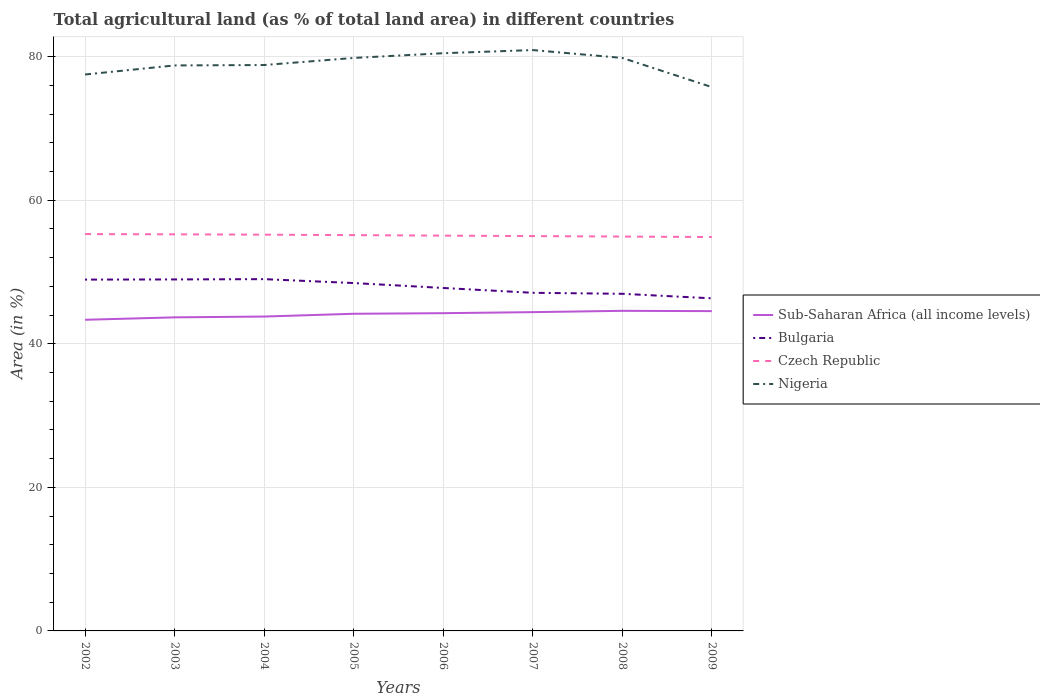How many different coloured lines are there?
Keep it short and to the point. 4. Does the line corresponding to Nigeria intersect with the line corresponding to Bulgaria?
Make the answer very short. No. Is the number of lines equal to the number of legend labels?
Your answer should be compact. Yes. Across all years, what is the maximum percentage of agricultural land in Nigeria?
Provide a succinct answer. 75.76. In which year was the percentage of agricultural land in Bulgaria maximum?
Your answer should be compact. 2009. What is the total percentage of agricultural land in Nigeria in the graph?
Offer a very short reply. -0.66. What is the difference between the highest and the second highest percentage of agricultural land in Sub-Saharan Africa (all income levels)?
Your response must be concise. 1.25. How many years are there in the graph?
Your response must be concise. 8. Where does the legend appear in the graph?
Keep it short and to the point. Center right. How are the legend labels stacked?
Your response must be concise. Vertical. What is the title of the graph?
Offer a very short reply. Total agricultural land (as % of total land area) in different countries. Does "San Marino" appear as one of the legend labels in the graph?
Your answer should be compact. No. What is the label or title of the X-axis?
Your response must be concise. Years. What is the label or title of the Y-axis?
Offer a very short reply. Area (in %). What is the Area (in %) in Sub-Saharan Africa (all income levels) in 2002?
Offer a terse response. 43.34. What is the Area (in %) in Bulgaria in 2002?
Provide a short and direct response. 48.94. What is the Area (in %) in Czech Republic in 2002?
Offer a very short reply. 55.29. What is the Area (in %) in Nigeria in 2002?
Make the answer very short. 77.52. What is the Area (in %) in Sub-Saharan Africa (all income levels) in 2003?
Your response must be concise. 43.68. What is the Area (in %) in Bulgaria in 2003?
Offer a terse response. 48.97. What is the Area (in %) of Czech Republic in 2003?
Provide a succinct answer. 55.25. What is the Area (in %) in Nigeria in 2003?
Keep it short and to the point. 78.78. What is the Area (in %) in Sub-Saharan Africa (all income levels) in 2004?
Your answer should be very brief. 43.8. What is the Area (in %) in Bulgaria in 2004?
Give a very brief answer. 49.01. What is the Area (in %) in Czech Republic in 2004?
Ensure brevity in your answer.  55.2. What is the Area (in %) in Nigeria in 2004?
Make the answer very short. 78.83. What is the Area (in %) in Sub-Saharan Africa (all income levels) in 2005?
Ensure brevity in your answer.  44.18. What is the Area (in %) in Bulgaria in 2005?
Your answer should be compact. 48.46. What is the Area (in %) of Czech Republic in 2005?
Offer a terse response. 55.14. What is the Area (in %) in Nigeria in 2005?
Make the answer very short. 79.82. What is the Area (in %) in Sub-Saharan Africa (all income levels) in 2006?
Your answer should be compact. 44.26. What is the Area (in %) in Bulgaria in 2006?
Your answer should be very brief. 47.78. What is the Area (in %) in Czech Republic in 2006?
Keep it short and to the point. 55.07. What is the Area (in %) of Nigeria in 2006?
Offer a terse response. 80.48. What is the Area (in %) in Sub-Saharan Africa (all income levels) in 2007?
Offer a terse response. 44.41. What is the Area (in %) in Bulgaria in 2007?
Keep it short and to the point. 47.1. What is the Area (in %) in Czech Republic in 2007?
Offer a terse response. 55. What is the Area (in %) of Nigeria in 2007?
Provide a succinct answer. 80.92. What is the Area (in %) of Sub-Saharan Africa (all income levels) in 2008?
Offer a terse response. 44.59. What is the Area (in %) of Bulgaria in 2008?
Offer a very short reply. 46.97. What is the Area (in %) of Czech Republic in 2008?
Keep it short and to the point. 54.94. What is the Area (in %) of Nigeria in 2008?
Ensure brevity in your answer.  79.82. What is the Area (in %) in Sub-Saharan Africa (all income levels) in 2009?
Offer a terse response. 44.55. What is the Area (in %) in Bulgaria in 2009?
Make the answer very short. 46.33. What is the Area (in %) in Czech Republic in 2009?
Provide a succinct answer. 54.87. What is the Area (in %) of Nigeria in 2009?
Provide a short and direct response. 75.76. Across all years, what is the maximum Area (in %) of Sub-Saharan Africa (all income levels)?
Give a very brief answer. 44.59. Across all years, what is the maximum Area (in %) in Bulgaria?
Give a very brief answer. 49.01. Across all years, what is the maximum Area (in %) of Czech Republic?
Ensure brevity in your answer.  55.29. Across all years, what is the maximum Area (in %) in Nigeria?
Your answer should be compact. 80.92. Across all years, what is the minimum Area (in %) in Sub-Saharan Africa (all income levels)?
Your answer should be compact. 43.34. Across all years, what is the minimum Area (in %) of Bulgaria?
Provide a short and direct response. 46.33. Across all years, what is the minimum Area (in %) of Czech Republic?
Provide a short and direct response. 54.87. Across all years, what is the minimum Area (in %) in Nigeria?
Keep it short and to the point. 75.76. What is the total Area (in %) of Sub-Saharan Africa (all income levels) in the graph?
Ensure brevity in your answer.  352.83. What is the total Area (in %) in Bulgaria in the graph?
Your response must be concise. 383.56. What is the total Area (in %) of Czech Republic in the graph?
Ensure brevity in your answer.  440.76. What is the total Area (in %) of Nigeria in the graph?
Make the answer very short. 631.94. What is the difference between the Area (in %) of Sub-Saharan Africa (all income levels) in 2002 and that in 2003?
Give a very brief answer. -0.34. What is the difference between the Area (in %) of Bulgaria in 2002 and that in 2003?
Offer a very short reply. -0.02. What is the difference between the Area (in %) of Czech Republic in 2002 and that in 2003?
Provide a succinct answer. 0.04. What is the difference between the Area (in %) of Nigeria in 2002 and that in 2003?
Your answer should be compact. -1.26. What is the difference between the Area (in %) in Sub-Saharan Africa (all income levels) in 2002 and that in 2004?
Ensure brevity in your answer.  -0.45. What is the difference between the Area (in %) of Bulgaria in 2002 and that in 2004?
Your answer should be very brief. -0.06. What is the difference between the Area (in %) of Czech Republic in 2002 and that in 2004?
Keep it short and to the point. 0.08. What is the difference between the Area (in %) in Nigeria in 2002 and that in 2004?
Give a very brief answer. -1.32. What is the difference between the Area (in %) of Sub-Saharan Africa (all income levels) in 2002 and that in 2005?
Offer a very short reply. -0.84. What is the difference between the Area (in %) of Bulgaria in 2002 and that in 2005?
Provide a succinct answer. 0.48. What is the difference between the Area (in %) of Czech Republic in 2002 and that in 2005?
Provide a succinct answer. 0.15. What is the difference between the Area (in %) of Nigeria in 2002 and that in 2005?
Provide a succinct answer. -2.31. What is the difference between the Area (in %) of Sub-Saharan Africa (all income levels) in 2002 and that in 2006?
Offer a terse response. -0.92. What is the difference between the Area (in %) in Bulgaria in 2002 and that in 2006?
Give a very brief answer. 1.17. What is the difference between the Area (in %) in Czech Republic in 2002 and that in 2006?
Your answer should be compact. 0.22. What is the difference between the Area (in %) in Nigeria in 2002 and that in 2006?
Provide a succinct answer. -2.96. What is the difference between the Area (in %) in Sub-Saharan Africa (all income levels) in 2002 and that in 2007?
Make the answer very short. -1.07. What is the difference between the Area (in %) of Bulgaria in 2002 and that in 2007?
Ensure brevity in your answer.  1.84. What is the difference between the Area (in %) of Czech Republic in 2002 and that in 2007?
Make the answer very short. 0.28. What is the difference between the Area (in %) in Nigeria in 2002 and that in 2007?
Offer a very short reply. -3.4. What is the difference between the Area (in %) in Sub-Saharan Africa (all income levels) in 2002 and that in 2008?
Offer a terse response. -1.25. What is the difference between the Area (in %) of Bulgaria in 2002 and that in 2008?
Your response must be concise. 1.98. What is the difference between the Area (in %) in Czech Republic in 2002 and that in 2008?
Your response must be concise. 0.35. What is the difference between the Area (in %) of Nigeria in 2002 and that in 2008?
Your response must be concise. -2.31. What is the difference between the Area (in %) in Sub-Saharan Africa (all income levels) in 2002 and that in 2009?
Offer a terse response. -1.21. What is the difference between the Area (in %) of Bulgaria in 2002 and that in 2009?
Offer a very short reply. 2.61. What is the difference between the Area (in %) in Czech Republic in 2002 and that in 2009?
Offer a terse response. 0.41. What is the difference between the Area (in %) in Nigeria in 2002 and that in 2009?
Offer a very short reply. 1.76. What is the difference between the Area (in %) in Sub-Saharan Africa (all income levels) in 2003 and that in 2004?
Ensure brevity in your answer.  -0.11. What is the difference between the Area (in %) in Bulgaria in 2003 and that in 2004?
Ensure brevity in your answer.  -0.04. What is the difference between the Area (in %) in Czech Republic in 2003 and that in 2004?
Keep it short and to the point. 0.04. What is the difference between the Area (in %) of Nigeria in 2003 and that in 2004?
Ensure brevity in your answer.  -0.05. What is the difference between the Area (in %) in Sub-Saharan Africa (all income levels) in 2003 and that in 2005?
Offer a very short reply. -0.5. What is the difference between the Area (in %) of Bulgaria in 2003 and that in 2005?
Provide a short and direct response. 0.5. What is the difference between the Area (in %) in Czech Republic in 2003 and that in 2005?
Provide a short and direct response. 0.11. What is the difference between the Area (in %) of Nigeria in 2003 and that in 2005?
Give a very brief answer. -1.04. What is the difference between the Area (in %) in Sub-Saharan Africa (all income levels) in 2003 and that in 2006?
Keep it short and to the point. -0.58. What is the difference between the Area (in %) of Bulgaria in 2003 and that in 2006?
Ensure brevity in your answer.  1.19. What is the difference between the Area (in %) in Czech Republic in 2003 and that in 2006?
Keep it short and to the point. 0.18. What is the difference between the Area (in %) in Nigeria in 2003 and that in 2006?
Provide a succinct answer. -1.7. What is the difference between the Area (in %) of Sub-Saharan Africa (all income levels) in 2003 and that in 2007?
Give a very brief answer. -0.73. What is the difference between the Area (in %) of Bulgaria in 2003 and that in 2007?
Provide a succinct answer. 1.86. What is the difference between the Area (in %) in Czech Republic in 2003 and that in 2007?
Provide a short and direct response. 0.24. What is the difference between the Area (in %) in Nigeria in 2003 and that in 2007?
Offer a terse response. -2.14. What is the difference between the Area (in %) of Sub-Saharan Africa (all income levels) in 2003 and that in 2008?
Keep it short and to the point. -0.91. What is the difference between the Area (in %) in Bulgaria in 2003 and that in 2008?
Keep it short and to the point. 2. What is the difference between the Area (in %) of Czech Republic in 2003 and that in 2008?
Provide a succinct answer. 0.31. What is the difference between the Area (in %) in Nigeria in 2003 and that in 2008?
Offer a very short reply. -1.04. What is the difference between the Area (in %) of Sub-Saharan Africa (all income levels) in 2003 and that in 2009?
Your answer should be very brief. -0.87. What is the difference between the Area (in %) of Bulgaria in 2003 and that in 2009?
Your answer should be compact. 2.63. What is the difference between the Area (in %) in Czech Republic in 2003 and that in 2009?
Ensure brevity in your answer.  0.37. What is the difference between the Area (in %) of Nigeria in 2003 and that in 2009?
Provide a short and direct response. 3.02. What is the difference between the Area (in %) of Sub-Saharan Africa (all income levels) in 2004 and that in 2005?
Your response must be concise. -0.39. What is the difference between the Area (in %) in Bulgaria in 2004 and that in 2005?
Provide a succinct answer. 0.54. What is the difference between the Area (in %) of Czech Republic in 2004 and that in 2005?
Your answer should be compact. 0.06. What is the difference between the Area (in %) of Nigeria in 2004 and that in 2005?
Make the answer very short. -0.99. What is the difference between the Area (in %) of Sub-Saharan Africa (all income levels) in 2004 and that in 2006?
Offer a very short reply. -0.47. What is the difference between the Area (in %) of Bulgaria in 2004 and that in 2006?
Your response must be concise. 1.23. What is the difference between the Area (in %) of Czech Republic in 2004 and that in 2006?
Your answer should be very brief. 0.14. What is the difference between the Area (in %) in Nigeria in 2004 and that in 2006?
Your answer should be compact. -1.65. What is the difference between the Area (in %) in Sub-Saharan Africa (all income levels) in 2004 and that in 2007?
Offer a terse response. -0.61. What is the difference between the Area (in %) of Bulgaria in 2004 and that in 2007?
Offer a very short reply. 1.9. What is the difference between the Area (in %) of Nigeria in 2004 and that in 2007?
Ensure brevity in your answer.  -2.09. What is the difference between the Area (in %) in Sub-Saharan Africa (all income levels) in 2004 and that in 2008?
Ensure brevity in your answer.  -0.8. What is the difference between the Area (in %) of Bulgaria in 2004 and that in 2008?
Provide a succinct answer. 2.04. What is the difference between the Area (in %) of Czech Republic in 2004 and that in 2008?
Offer a very short reply. 0.26. What is the difference between the Area (in %) of Nigeria in 2004 and that in 2008?
Keep it short and to the point. -0.99. What is the difference between the Area (in %) in Sub-Saharan Africa (all income levels) in 2004 and that in 2009?
Offer a terse response. -0.75. What is the difference between the Area (in %) in Bulgaria in 2004 and that in 2009?
Make the answer very short. 2.67. What is the difference between the Area (in %) of Czech Republic in 2004 and that in 2009?
Provide a short and direct response. 0.33. What is the difference between the Area (in %) of Nigeria in 2004 and that in 2009?
Keep it short and to the point. 3.07. What is the difference between the Area (in %) of Sub-Saharan Africa (all income levels) in 2005 and that in 2006?
Provide a short and direct response. -0.08. What is the difference between the Area (in %) of Bulgaria in 2005 and that in 2006?
Ensure brevity in your answer.  0.69. What is the difference between the Area (in %) of Czech Republic in 2005 and that in 2006?
Make the answer very short. 0.07. What is the difference between the Area (in %) in Nigeria in 2005 and that in 2006?
Your answer should be compact. -0.66. What is the difference between the Area (in %) in Sub-Saharan Africa (all income levels) in 2005 and that in 2007?
Your answer should be compact. -0.23. What is the difference between the Area (in %) in Bulgaria in 2005 and that in 2007?
Ensure brevity in your answer.  1.36. What is the difference between the Area (in %) of Czech Republic in 2005 and that in 2007?
Your answer should be compact. 0.14. What is the difference between the Area (in %) of Nigeria in 2005 and that in 2007?
Your response must be concise. -1.1. What is the difference between the Area (in %) of Sub-Saharan Africa (all income levels) in 2005 and that in 2008?
Keep it short and to the point. -0.41. What is the difference between the Area (in %) in Bulgaria in 2005 and that in 2008?
Offer a terse response. 1.5. What is the difference between the Area (in %) of Czech Republic in 2005 and that in 2008?
Offer a very short reply. 0.2. What is the difference between the Area (in %) in Sub-Saharan Africa (all income levels) in 2005 and that in 2009?
Provide a succinct answer. -0.37. What is the difference between the Area (in %) in Bulgaria in 2005 and that in 2009?
Provide a succinct answer. 2.13. What is the difference between the Area (in %) of Czech Republic in 2005 and that in 2009?
Keep it short and to the point. 0.26. What is the difference between the Area (in %) in Nigeria in 2005 and that in 2009?
Offer a terse response. 4.06. What is the difference between the Area (in %) of Sub-Saharan Africa (all income levels) in 2006 and that in 2007?
Your response must be concise. -0.15. What is the difference between the Area (in %) in Bulgaria in 2006 and that in 2007?
Keep it short and to the point. 0.67. What is the difference between the Area (in %) in Czech Republic in 2006 and that in 2007?
Offer a very short reply. 0.06. What is the difference between the Area (in %) of Nigeria in 2006 and that in 2007?
Offer a very short reply. -0.44. What is the difference between the Area (in %) in Sub-Saharan Africa (all income levels) in 2006 and that in 2008?
Provide a short and direct response. -0.33. What is the difference between the Area (in %) in Bulgaria in 2006 and that in 2008?
Offer a very short reply. 0.81. What is the difference between the Area (in %) of Czech Republic in 2006 and that in 2008?
Provide a succinct answer. 0.13. What is the difference between the Area (in %) of Nigeria in 2006 and that in 2008?
Keep it short and to the point. 0.66. What is the difference between the Area (in %) of Sub-Saharan Africa (all income levels) in 2006 and that in 2009?
Give a very brief answer. -0.29. What is the difference between the Area (in %) in Bulgaria in 2006 and that in 2009?
Your answer should be compact. 1.44. What is the difference between the Area (in %) in Czech Republic in 2006 and that in 2009?
Your answer should be compact. 0.19. What is the difference between the Area (in %) of Nigeria in 2006 and that in 2009?
Give a very brief answer. 4.72. What is the difference between the Area (in %) of Sub-Saharan Africa (all income levels) in 2007 and that in 2008?
Provide a succinct answer. -0.18. What is the difference between the Area (in %) in Bulgaria in 2007 and that in 2008?
Offer a very short reply. 0.14. What is the difference between the Area (in %) of Czech Republic in 2007 and that in 2008?
Ensure brevity in your answer.  0.06. What is the difference between the Area (in %) of Nigeria in 2007 and that in 2008?
Offer a very short reply. 1.1. What is the difference between the Area (in %) of Sub-Saharan Africa (all income levels) in 2007 and that in 2009?
Your answer should be very brief. -0.14. What is the difference between the Area (in %) in Bulgaria in 2007 and that in 2009?
Provide a succinct answer. 0.77. What is the difference between the Area (in %) of Czech Republic in 2007 and that in 2009?
Offer a very short reply. 0.13. What is the difference between the Area (in %) in Nigeria in 2007 and that in 2009?
Your response must be concise. 5.16. What is the difference between the Area (in %) in Sub-Saharan Africa (all income levels) in 2008 and that in 2009?
Offer a very short reply. 0.04. What is the difference between the Area (in %) of Bulgaria in 2008 and that in 2009?
Your response must be concise. 0.63. What is the difference between the Area (in %) of Czech Republic in 2008 and that in 2009?
Provide a succinct answer. 0.06. What is the difference between the Area (in %) in Nigeria in 2008 and that in 2009?
Provide a succinct answer. 4.06. What is the difference between the Area (in %) in Sub-Saharan Africa (all income levels) in 2002 and the Area (in %) in Bulgaria in 2003?
Keep it short and to the point. -5.62. What is the difference between the Area (in %) in Sub-Saharan Africa (all income levels) in 2002 and the Area (in %) in Czech Republic in 2003?
Your response must be concise. -11.9. What is the difference between the Area (in %) of Sub-Saharan Africa (all income levels) in 2002 and the Area (in %) of Nigeria in 2003?
Offer a terse response. -35.43. What is the difference between the Area (in %) of Bulgaria in 2002 and the Area (in %) of Czech Republic in 2003?
Give a very brief answer. -6.3. What is the difference between the Area (in %) in Bulgaria in 2002 and the Area (in %) in Nigeria in 2003?
Make the answer very short. -29.84. What is the difference between the Area (in %) of Czech Republic in 2002 and the Area (in %) of Nigeria in 2003?
Offer a very short reply. -23.49. What is the difference between the Area (in %) in Sub-Saharan Africa (all income levels) in 2002 and the Area (in %) in Bulgaria in 2004?
Provide a short and direct response. -5.66. What is the difference between the Area (in %) in Sub-Saharan Africa (all income levels) in 2002 and the Area (in %) in Czech Republic in 2004?
Provide a succinct answer. -11.86. What is the difference between the Area (in %) of Sub-Saharan Africa (all income levels) in 2002 and the Area (in %) of Nigeria in 2004?
Offer a terse response. -35.49. What is the difference between the Area (in %) of Bulgaria in 2002 and the Area (in %) of Czech Republic in 2004?
Ensure brevity in your answer.  -6.26. What is the difference between the Area (in %) in Bulgaria in 2002 and the Area (in %) in Nigeria in 2004?
Give a very brief answer. -29.89. What is the difference between the Area (in %) of Czech Republic in 2002 and the Area (in %) of Nigeria in 2004?
Offer a terse response. -23.55. What is the difference between the Area (in %) of Sub-Saharan Africa (all income levels) in 2002 and the Area (in %) of Bulgaria in 2005?
Offer a very short reply. -5.12. What is the difference between the Area (in %) in Sub-Saharan Africa (all income levels) in 2002 and the Area (in %) in Czech Republic in 2005?
Make the answer very short. -11.79. What is the difference between the Area (in %) of Sub-Saharan Africa (all income levels) in 2002 and the Area (in %) of Nigeria in 2005?
Give a very brief answer. -36.48. What is the difference between the Area (in %) of Bulgaria in 2002 and the Area (in %) of Czech Republic in 2005?
Give a very brief answer. -6.2. What is the difference between the Area (in %) of Bulgaria in 2002 and the Area (in %) of Nigeria in 2005?
Your answer should be very brief. -30.88. What is the difference between the Area (in %) in Czech Republic in 2002 and the Area (in %) in Nigeria in 2005?
Keep it short and to the point. -24.54. What is the difference between the Area (in %) in Sub-Saharan Africa (all income levels) in 2002 and the Area (in %) in Bulgaria in 2006?
Keep it short and to the point. -4.43. What is the difference between the Area (in %) of Sub-Saharan Africa (all income levels) in 2002 and the Area (in %) of Czech Republic in 2006?
Offer a terse response. -11.72. What is the difference between the Area (in %) of Sub-Saharan Africa (all income levels) in 2002 and the Area (in %) of Nigeria in 2006?
Ensure brevity in your answer.  -37.14. What is the difference between the Area (in %) of Bulgaria in 2002 and the Area (in %) of Czech Republic in 2006?
Your response must be concise. -6.12. What is the difference between the Area (in %) in Bulgaria in 2002 and the Area (in %) in Nigeria in 2006?
Provide a short and direct response. -31.54. What is the difference between the Area (in %) of Czech Republic in 2002 and the Area (in %) of Nigeria in 2006?
Your response must be concise. -25.19. What is the difference between the Area (in %) of Sub-Saharan Africa (all income levels) in 2002 and the Area (in %) of Bulgaria in 2007?
Your response must be concise. -3.76. What is the difference between the Area (in %) in Sub-Saharan Africa (all income levels) in 2002 and the Area (in %) in Czech Republic in 2007?
Give a very brief answer. -11.66. What is the difference between the Area (in %) of Sub-Saharan Africa (all income levels) in 2002 and the Area (in %) of Nigeria in 2007?
Provide a short and direct response. -37.58. What is the difference between the Area (in %) of Bulgaria in 2002 and the Area (in %) of Czech Republic in 2007?
Your response must be concise. -6.06. What is the difference between the Area (in %) of Bulgaria in 2002 and the Area (in %) of Nigeria in 2007?
Make the answer very short. -31.98. What is the difference between the Area (in %) of Czech Republic in 2002 and the Area (in %) of Nigeria in 2007?
Offer a very short reply. -25.63. What is the difference between the Area (in %) in Sub-Saharan Africa (all income levels) in 2002 and the Area (in %) in Bulgaria in 2008?
Offer a very short reply. -3.62. What is the difference between the Area (in %) in Sub-Saharan Africa (all income levels) in 2002 and the Area (in %) in Czech Republic in 2008?
Make the answer very short. -11.59. What is the difference between the Area (in %) in Sub-Saharan Africa (all income levels) in 2002 and the Area (in %) in Nigeria in 2008?
Give a very brief answer. -36.48. What is the difference between the Area (in %) in Bulgaria in 2002 and the Area (in %) in Czech Republic in 2008?
Provide a succinct answer. -6. What is the difference between the Area (in %) in Bulgaria in 2002 and the Area (in %) in Nigeria in 2008?
Ensure brevity in your answer.  -30.88. What is the difference between the Area (in %) in Czech Republic in 2002 and the Area (in %) in Nigeria in 2008?
Provide a short and direct response. -24.54. What is the difference between the Area (in %) of Sub-Saharan Africa (all income levels) in 2002 and the Area (in %) of Bulgaria in 2009?
Offer a terse response. -2.99. What is the difference between the Area (in %) of Sub-Saharan Africa (all income levels) in 2002 and the Area (in %) of Czech Republic in 2009?
Provide a succinct answer. -11.53. What is the difference between the Area (in %) in Sub-Saharan Africa (all income levels) in 2002 and the Area (in %) in Nigeria in 2009?
Keep it short and to the point. -32.42. What is the difference between the Area (in %) in Bulgaria in 2002 and the Area (in %) in Czech Republic in 2009?
Offer a terse response. -5.93. What is the difference between the Area (in %) in Bulgaria in 2002 and the Area (in %) in Nigeria in 2009?
Make the answer very short. -26.82. What is the difference between the Area (in %) of Czech Republic in 2002 and the Area (in %) of Nigeria in 2009?
Give a very brief answer. -20.47. What is the difference between the Area (in %) of Sub-Saharan Africa (all income levels) in 2003 and the Area (in %) of Bulgaria in 2004?
Offer a terse response. -5.33. What is the difference between the Area (in %) in Sub-Saharan Africa (all income levels) in 2003 and the Area (in %) in Czech Republic in 2004?
Make the answer very short. -11.52. What is the difference between the Area (in %) of Sub-Saharan Africa (all income levels) in 2003 and the Area (in %) of Nigeria in 2004?
Give a very brief answer. -35.15. What is the difference between the Area (in %) in Bulgaria in 2003 and the Area (in %) in Czech Republic in 2004?
Provide a short and direct response. -6.24. What is the difference between the Area (in %) in Bulgaria in 2003 and the Area (in %) in Nigeria in 2004?
Ensure brevity in your answer.  -29.87. What is the difference between the Area (in %) of Czech Republic in 2003 and the Area (in %) of Nigeria in 2004?
Your answer should be very brief. -23.59. What is the difference between the Area (in %) in Sub-Saharan Africa (all income levels) in 2003 and the Area (in %) in Bulgaria in 2005?
Offer a very short reply. -4.78. What is the difference between the Area (in %) in Sub-Saharan Africa (all income levels) in 2003 and the Area (in %) in Czech Republic in 2005?
Your answer should be compact. -11.46. What is the difference between the Area (in %) of Sub-Saharan Africa (all income levels) in 2003 and the Area (in %) of Nigeria in 2005?
Keep it short and to the point. -36.14. What is the difference between the Area (in %) in Bulgaria in 2003 and the Area (in %) in Czech Republic in 2005?
Provide a short and direct response. -6.17. What is the difference between the Area (in %) in Bulgaria in 2003 and the Area (in %) in Nigeria in 2005?
Your answer should be compact. -30.86. What is the difference between the Area (in %) of Czech Republic in 2003 and the Area (in %) of Nigeria in 2005?
Offer a terse response. -24.57. What is the difference between the Area (in %) of Sub-Saharan Africa (all income levels) in 2003 and the Area (in %) of Bulgaria in 2006?
Your answer should be compact. -4.09. What is the difference between the Area (in %) of Sub-Saharan Africa (all income levels) in 2003 and the Area (in %) of Czech Republic in 2006?
Your answer should be compact. -11.39. What is the difference between the Area (in %) in Sub-Saharan Africa (all income levels) in 2003 and the Area (in %) in Nigeria in 2006?
Ensure brevity in your answer.  -36.8. What is the difference between the Area (in %) of Bulgaria in 2003 and the Area (in %) of Czech Republic in 2006?
Provide a succinct answer. -6.1. What is the difference between the Area (in %) of Bulgaria in 2003 and the Area (in %) of Nigeria in 2006?
Provide a succinct answer. -31.52. What is the difference between the Area (in %) in Czech Republic in 2003 and the Area (in %) in Nigeria in 2006?
Make the answer very short. -25.23. What is the difference between the Area (in %) of Sub-Saharan Africa (all income levels) in 2003 and the Area (in %) of Bulgaria in 2007?
Ensure brevity in your answer.  -3.42. What is the difference between the Area (in %) of Sub-Saharan Africa (all income levels) in 2003 and the Area (in %) of Czech Republic in 2007?
Provide a short and direct response. -11.32. What is the difference between the Area (in %) in Sub-Saharan Africa (all income levels) in 2003 and the Area (in %) in Nigeria in 2007?
Offer a terse response. -37.24. What is the difference between the Area (in %) in Bulgaria in 2003 and the Area (in %) in Czech Republic in 2007?
Your response must be concise. -6.04. What is the difference between the Area (in %) of Bulgaria in 2003 and the Area (in %) of Nigeria in 2007?
Make the answer very short. -31.95. What is the difference between the Area (in %) in Czech Republic in 2003 and the Area (in %) in Nigeria in 2007?
Provide a short and direct response. -25.67. What is the difference between the Area (in %) of Sub-Saharan Africa (all income levels) in 2003 and the Area (in %) of Bulgaria in 2008?
Offer a terse response. -3.28. What is the difference between the Area (in %) of Sub-Saharan Africa (all income levels) in 2003 and the Area (in %) of Czech Republic in 2008?
Your answer should be very brief. -11.26. What is the difference between the Area (in %) in Sub-Saharan Africa (all income levels) in 2003 and the Area (in %) in Nigeria in 2008?
Offer a terse response. -36.14. What is the difference between the Area (in %) in Bulgaria in 2003 and the Area (in %) in Czech Republic in 2008?
Keep it short and to the point. -5.97. What is the difference between the Area (in %) in Bulgaria in 2003 and the Area (in %) in Nigeria in 2008?
Keep it short and to the point. -30.86. What is the difference between the Area (in %) of Czech Republic in 2003 and the Area (in %) of Nigeria in 2008?
Provide a short and direct response. -24.57. What is the difference between the Area (in %) of Sub-Saharan Africa (all income levels) in 2003 and the Area (in %) of Bulgaria in 2009?
Keep it short and to the point. -2.65. What is the difference between the Area (in %) of Sub-Saharan Africa (all income levels) in 2003 and the Area (in %) of Czech Republic in 2009?
Make the answer very short. -11.19. What is the difference between the Area (in %) in Sub-Saharan Africa (all income levels) in 2003 and the Area (in %) in Nigeria in 2009?
Keep it short and to the point. -32.08. What is the difference between the Area (in %) of Bulgaria in 2003 and the Area (in %) of Czech Republic in 2009?
Give a very brief answer. -5.91. What is the difference between the Area (in %) of Bulgaria in 2003 and the Area (in %) of Nigeria in 2009?
Offer a very short reply. -26.79. What is the difference between the Area (in %) of Czech Republic in 2003 and the Area (in %) of Nigeria in 2009?
Provide a short and direct response. -20.51. What is the difference between the Area (in %) in Sub-Saharan Africa (all income levels) in 2004 and the Area (in %) in Bulgaria in 2005?
Give a very brief answer. -4.67. What is the difference between the Area (in %) in Sub-Saharan Africa (all income levels) in 2004 and the Area (in %) in Czech Republic in 2005?
Your answer should be very brief. -11.34. What is the difference between the Area (in %) of Sub-Saharan Africa (all income levels) in 2004 and the Area (in %) of Nigeria in 2005?
Your answer should be compact. -36.03. What is the difference between the Area (in %) in Bulgaria in 2004 and the Area (in %) in Czech Republic in 2005?
Keep it short and to the point. -6.13. What is the difference between the Area (in %) of Bulgaria in 2004 and the Area (in %) of Nigeria in 2005?
Offer a very short reply. -30.82. What is the difference between the Area (in %) in Czech Republic in 2004 and the Area (in %) in Nigeria in 2005?
Make the answer very short. -24.62. What is the difference between the Area (in %) in Sub-Saharan Africa (all income levels) in 2004 and the Area (in %) in Bulgaria in 2006?
Offer a very short reply. -3.98. What is the difference between the Area (in %) of Sub-Saharan Africa (all income levels) in 2004 and the Area (in %) of Czech Republic in 2006?
Offer a very short reply. -11.27. What is the difference between the Area (in %) in Sub-Saharan Africa (all income levels) in 2004 and the Area (in %) in Nigeria in 2006?
Keep it short and to the point. -36.69. What is the difference between the Area (in %) in Bulgaria in 2004 and the Area (in %) in Czech Republic in 2006?
Offer a terse response. -6.06. What is the difference between the Area (in %) in Bulgaria in 2004 and the Area (in %) in Nigeria in 2006?
Provide a succinct answer. -31.47. What is the difference between the Area (in %) in Czech Republic in 2004 and the Area (in %) in Nigeria in 2006?
Give a very brief answer. -25.28. What is the difference between the Area (in %) in Sub-Saharan Africa (all income levels) in 2004 and the Area (in %) in Bulgaria in 2007?
Make the answer very short. -3.31. What is the difference between the Area (in %) of Sub-Saharan Africa (all income levels) in 2004 and the Area (in %) of Czech Republic in 2007?
Your answer should be compact. -11.21. What is the difference between the Area (in %) of Sub-Saharan Africa (all income levels) in 2004 and the Area (in %) of Nigeria in 2007?
Your answer should be very brief. -37.12. What is the difference between the Area (in %) of Bulgaria in 2004 and the Area (in %) of Czech Republic in 2007?
Make the answer very short. -6. What is the difference between the Area (in %) in Bulgaria in 2004 and the Area (in %) in Nigeria in 2007?
Give a very brief answer. -31.91. What is the difference between the Area (in %) in Czech Republic in 2004 and the Area (in %) in Nigeria in 2007?
Provide a short and direct response. -25.72. What is the difference between the Area (in %) of Sub-Saharan Africa (all income levels) in 2004 and the Area (in %) of Bulgaria in 2008?
Your answer should be compact. -3.17. What is the difference between the Area (in %) in Sub-Saharan Africa (all income levels) in 2004 and the Area (in %) in Czech Republic in 2008?
Ensure brevity in your answer.  -11.14. What is the difference between the Area (in %) in Sub-Saharan Africa (all income levels) in 2004 and the Area (in %) in Nigeria in 2008?
Keep it short and to the point. -36.03. What is the difference between the Area (in %) in Bulgaria in 2004 and the Area (in %) in Czech Republic in 2008?
Give a very brief answer. -5.93. What is the difference between the Area (in %) of Bulgaria in 2004 and the Area (in %) of Nigeria in 2008?
Make the answer very short. -30.82. What is the difference between the Area (in %) of Czech Republic in 2004 and the Area (in %) of Nigeria in 2008?
Make the answer very short. -24.62. What is the difference between the Area (in %) in Sub-Saharan Africa (all income levels) in 2004 and the Area (in %) in Bulgaria in 2009?
Give a very brief answer. -2.54. What is the difference between the Area (in %) in Sub-Saharan Africa (all income levels) in 2004 and the Area (in %) in Czech Republic in 2009?
Your answer should be very brief. -11.08. What is the difference between the Area (in %) of Sub-Saharan Africa (all income levels) in 2004 and the Area (in %) of Nigeria in 2009?
Offer a terse response. -31.96. What is the difference between the Area (in %) in Bulgaria in 2004 and the Area (in %) in Czech Republic in 2009?
Your answer should be very brief. -5.87. What is the difference between the Area (in %) in Bulgaria in 2004 and the Area (in %) in Nigeria in 2009?
Offer a terse response. -26.75. What is the difference between the Area (in %) in Czech Republic in 2004 and the Area (in %) in Nigeria in 2009?
Give a very brief answer. -20.56. What is the difference between the Area (in %) in Sub-Saharan Africa (all income levels) in 2005 and the Area (in %) in Bulgaria in 2006?
Give a very brief answer. -3.59. What is the difference between the Area (in %) in Sub-Saharan Africa (all income levels) in 2005 and the Area (in %) in Czech Republic in 2006?
Provide a short and direct response. -10.88. What is the difference between the Area (in %) of Sub-Saharan Africa (all income levels) in 2005 and the Area (in %) of Nigeria in 2006?
Provide a succinct answer. -36.3. What is the difference between the Area (in %) in Bulgaria in 2005 and the Area (in %) in Czech Republic in 2006?
Ensure brevity in your answer.  -6.61. What is the difference between the Area (in %) of Bulgaria in 2005 and the Area (in %) of Nigeria in 2006?
Your answer should be compact. -32.02. What is the difference between the Area (in %) in Czech Republic in 2005 and the Area (in %) in Nigeria in 2006?
Your answer should be very brief. -25.34. What is the difference between the Area (in %) in Sub-Saharan Africa (all income levels) in 2005 and the Area (in %) in Bulgaria in 2007?
Your response must be concise. -2.92. What is the difference between the Area (in %) in Sub-Saharan Africa (all income levels) in 2005 and the Area (in %) in Czech Republic in 2007?
Make the answer very short. -10.82. What is the difference between the Area (in %) in Sub-Saharan Africa (all income levels) in 2005 and the Area (in %) in Nigeria in 2007?
Your answer should be very brief. -36.74. What is the difference between the Area (in %) in Bulgaria in 2005 and the Area (in %) in Czech Republic in 2007?
Make the answer very short. -6.54. What is the difference between the Area (in %) in Bulgaria in 2005 and the Area (in %) in Nigeria in 2007?
Offer a terse response. -32.46. What is the difference between the Area (in %) of Czech Republic in 2005 and the Area (in %) of Nigeria in 2007?
Ensure brevity in your answer.  -25.78. What is the difference between the Area (in %) in Sub-Saharan Africa (all income levels) in 2005 and the Area (in %) in Bulgaria in 2008?
Offer a terse response. -2.78. What is the difference between the Area (in %) in Sub-Saharan Africa (all income levels) in 2005 and the Area (in %) in Czech Republic in 2008?
Ensure brevity in your answer.  -10.75. What is the difference between the Area (in %) in Sub-Saharan Africa (all income levels) in 2005 and the Area (in %) in Nigeria in 2008?
Ensure brevity in your answer.  -35.64. What is the difference between the Area (in %) in Bulgaria in 2005 and the Area (in %) in Czech Republic in 2008?
Your answer should be very brief. -6.48. What is the difference between the Area (in %) of Bulgaria in 2005 and the Area (in %) of Nigeria in 2008?
Make the answer very short. -31.36. What is the difference between the Area (in %) in Czech Republic in 2005 and the Area (in %) in Nigeria in 2008?
Offer a very short reply. -24.68. What is the difference between the Area (in %) in Sub-Saharan Africa (all income levels) in 2005 and the Area (in %) in Bulgaria in 2009?
Provide a short and direct response. -2.15. What is the difference between the Area (in %) in Sub-Saharan Africa (all income levels) in 2005 and the Area (in %) in Czech Republic in 2009?
Ensure brevity in your answer.  -10.69. What is the difference between the Area (in %) in Sub-Saharan Africa (all income levels) in 2005 and the Area (in %) in Nigeria in 2009?
Your answer should be compact. -31.58. What is the difference between the Area (in %) of Bulgaria in 2005 and the Area (in %) of Czech Republic in 2009?
Provide a succinct answer. -6.41. What is the difference between the Area (in %) of Bulgaria in 2005 and the Area (in %) of Nigeria in 2009?
Offer a very short reply. -27.3. What is the difference between the Area (in %) of Czech Republic in 2005 and the Area (in %) of Nigeria in 2009?
Your answer should be compact. -20.62. What is the difference between the Area (in %) of Sub-Saharan Africa (all income levels) in 2006 and the Area (in %) of Bulgaria in 2007?
Provide a short and direct response. -2.84. What is the difference between the Area (in %) of Sub-Saharan Africa (all income levels) in 2006 and the Area (in %) of Czech Republic in 2007?
Your answer should be very brief. -10.74. What is the difference between the Area (in %) of Sub-Saharan Africa (all income levels) in 2006 and the Area (in %) of Nigeria in 2007?
Your answer should be very brief. -36.66. What is the difference between the Area (in %) of Bulgaria in 2006 and the Area (in %) of Czech Republic in 2007?
Offer a terse response. -7.23. What is the difference between the Area (in %) of Bulgaria in 2006 and the Area (in %) of Nigeria in 2007?
Your answer should be very brief. -33.14. What is the difference between the Area (in %) in Czech Republic in 2006 and the Area (in %) in Nigeria in 2007?
Your answer should be very brief. -25.85. What is the difference between the Area (in %) in Sub-Saharan Africa (all income levels) in 2006 and the Area (in %) in Bulgaria in 2008?
Your response must be concise. -2.7. What is the difference between the Area (in %) in Sub-Saharan Africa (all income levels) in 2006 and the Area (in %) in Czech Republic in 2008?
Provide a short and direct response. -10.67. What is the difference between the Area (in %) of Sub-Saharan Africa (all income levels) in 2006 and the Area (in %) of Nigeria in 2008?
Make the answer very short. -35.56. What is the difference between the Area (in %) of Bulgaria in 2006 and the Area (in %) of Czech Republic in 2008?
Give a very brief answer. -7.16. What is the difference between the Area (in %) in Bulgaria in 2006 and the Area (in %) in Nigeria in 2008?
Offer a very short reply. -32.05. What is the difference between the Area (in %) in Czech Republic in 2006 and the Area (in %) in Nigeria in 2008?
Offer a terse response. -24.75. What is the difference between the Area (in %) in Sub-Saharan Africa (all income levels) in 2006 and the Area (in %) in Bulgaria in 2009?
Offer a terse response. -2.07. What is the difference between the Area (in %) in Sub-Saharan Africa (all income levels) in 2006 and the Area (in %) in Czech Republic in 2009?
Your answer should be compact. -10.61. What is the difference between the Area (in %) of Sub-Saharan Africa (all income levels) in 2006 and the Area (in %) of Nigeria in 2009?
Your answer should be compact. -31.5. What is the difference between the Area (in %) of Bulgaria in 2006 and the Area (in %) of Czech Republic in 2009?
Provide a short and direct response. -7.1. What is the difference between the Area (in %) in Bulgaria in 2006 and the Area (in %) in Nigeria in 2009?
Your answer should be very brief. -27.98. What is the difference between the Area (in %) of Czech Republic in 2006 and the Area (in %) of Nigeria in 2009?
Provide a succinct answer. -20.69. What is the difference between the Area (in %) in Sub-Saharan Africa (all income levels) in 2007 and the Area (in %) in Bulgaria in 2008?
Make the answer very short. -2.56. What is the difference between the Area (in %) of Sub-Saharan Africa (all income levels) in 2007 and the Area (in %) of Czech Republic in 2008?
Give a very brief answer. -10.53. What is the difference between the Area (in %) in Sub-Saharan Africa (all income levels) in 2007 and the Area (in %) in Nigeria in 2008?
Offer a very short reply. -35.41. What is the difference between the Area (in %) in Bulgaria in 2007 and the Area (in %) in Czech Republic in 2008?
Your answer should be compact. -7.83. What is the difference between the Area (in %) of Bulgaria in 2007 and the Area (in %) of Nigeria in 2008?
Your answer should be compact. -32.72. What is the difference between the Area (in %) in Czech Republic in 2007 and the Area (in %) in Nigeria in 2008?
Provide a succinct answer. -24.82. What is the difference between the Area (in %) of Sub-Saharan Africa (all income levels) in 2007 and the Area (in %) of Bulgaria in 2009?
Offer a very short reply. -1.92. What is the difference between the Area (in %) in Sub-Saharan Africa (all income levels) in 2007 and the Area (in %) in Czech Republic in 2009?
Provide a short and direct response. -10.46. What is the difference between the Area (in %) in Sub-Saharan Africa (all income levels) in 2007 and the Area (in %) in Nigeria in 2009?
Your answer should be very brief. -31.35. What is the difference between the Area (in %) of Bulgaria in 2007 and the Area (in %) of Czech Republic in 2009?
Ensure brevity in your answer.  -7.77. What is the difference between the Area (in %) of Bulgaria in 2007 and the Area (in %) of Nigeria in 2009?
Ensure brevity in your answer.  -28.66. What is the difference between the Area (in %) in Czech Republic in 2007 and the Area (in %) in Nigeria in 2009?
Make the answer very short. -20.76. What is the difference between the Area (in %) of Sub-Saharan Africa (all income levels) in 2008 and the Area (in %) of Bulgaria in 2009?
Ensure brevity in your answer.  -1.74. What is the difference between the Area (in %) of Sub-Saharan Africa (all income levels) in 2008 and the Area (in %) of Czech Republic in 2009?
Ensure brevity in your answer.  -10.28. What is the difference between the Area (in %) in Sub-Saharan Africa (all income levels) in 2008 and the Area (in %) in Nigeria in 2009?
Provide a short and direct response. -31.17. What is the difference between the Area (in %) of Bulgaria in 2008 and the Area (in %) of Czech Republic in 2009?
Keep it short and to the point. -7.91. What is the difference between the Area (in %) in Bulgaria in 2008 and the Area (in %) in Nigeria in 2009?
Your answer should be compact. -28.79. What is the difference between the Area (in %) of Czech Republic in 2008 and the Area (in %) of Nigeria in 2009?
Keep it short and to the point. -20.82. What is the average Area (in %) in Sub-Saharan Africa (all income levels) per year?
Ensure brevity in your answer.  44.1. What is the average Area (in %) in Bulgaria per year?
Provide a short and direct response. 47.95. What is the average Area (in %) of Czech Republic per year?
Your response must be concise. 55.09. What is the average Area (in %) in Nigeria per year?
Your response must be concise. 78.99. In the year 2002, what is the difference between the Area (in %) in Sub-Saharan Africa (all income levels) and Area (in %) in Bulgaria?
Offer a terse response. -5.6. In the year 2002, what is the difference between the Area (in %) in Sub-Saharan Africa (all income levels) and Area (in %) in Czech Republic?
Your response must be concise. -11.94. In the year 2002, what is the difference between the Area (in %) in Sub-Saharan Africa (all income levels) and Area (in %) in Nigeria?
Your answer should be compact. -34.17. In the year 2002, what is the difference between the Area (in %) of Bulgaria and Area (in %) of Czech Republic?
Your answer should be compact. -6.34. In the year 2002, what is the difference between the Area (in %) of Bulgaria and Area (in %) of Nigeria?
Provide a succinct answer. -28.57. In the year 2002, what is the difference between the Area (in %) in Czech Republic and Area (in %) in Nigeria?
Your response must be concise. -22.23. In the year 2003, what is the difference between the Area (in %) of Sub-Saharan Africa (all income levels) and Area (in %) of Bulgaria?
Ensure brevity in your answer.  -5.28. In the year 2003, what is the difference between the Area (in %) in Sub-Saharan Africa (all income levels) and Area (in %) in Czech Republic?
Offer a terse response. -11.57. In the year 2003, what is the difference between the Area (in %) in Sub-Saharan Africa (all income levels) and Area (in %) in Nigeria?
Your answer should be compact. -35.1. In the year 2003, what is the difference between the Area (in %) in Bulgaria and Area (in %) in Czech Republic?
Make the answer very short. -6.28. In the year 2003, what is the difference between the Area (in %) of Bulgaria and Area (in %) of Nigeria?
Keep it short and to the point. -29.81. In the year 2003, what is the difference between the Area (in %) in Czech Republic and Area (in %) in Nigeria?
Your response must be concise. -23.53. In the year 2004, what is the difference between the Area (in %) in Sub-Saharan Africa (all income levels) and Area (in %) in Bulgaria?
Provide a short and direct response. -5.21. In the year 2004, what is the difference between the Area (in %) in Sub-Saharan Africa (all income levels) and Area (in %) in Czech Republic?
Your response must be concise. -11.41. In the year 2004, what is the difference between the Area (in %) in Sub-Saharan Africa (all income levels) and Area (in %) in Nigeria?
Your answer should be compact. -35.04. In the year 2004, what is the difference between the Area (in %) of Bulgaria and Area (in %) of Czech Republic?
Offer a very short reply. -6.2. In the year 2004, what is the difference between the Area (in %) of Bulgaria and Area (in %) of Nigeria?
Provide a succinct answer. -29.83. In the year 2004, what is the difference between the Area (in %) in Czech Republic and Area (in %) in Nigeria?
Keep it short and to the point. -23.63. In the year 2005, what is the difference between the Area (in %) in Sub-Saharan Africa (all income levels) and Area (in %) in Bulgaria?
Your answer should be very brief. -4.28. In the year 2005, what is the difference between the Area (in %) of Sub-Saharan Africa (all income levels) and Area (in %) of Czech Republic?
Your response must be concise. -10.95. In the year 2005, what is the difference between the Area (in %) in Sub-Saharan Africa (all income levels) and Area (in %) in Nigeria?
Your answer should be compact. -35.64. In the year 2005, what is the difference between the Area (in %) in Bulgaria and Area (in %) in Czech Republic?
Provide a succinct answer. -6.68. In the year 2005, what is the difference between the Area (in %) of Bulgaria and Area (in %) of Nigeria?
Provide a short and direct response. -31.36. In the year 2005, what is the difference between the Area (in %) in Czech Republic and Area (in %) in Nigeria?
Your response must be concise. -24.68. In the year 2006, what is the difference between the Area (in %) in Sub-Saharan Africa (all income levels) and Area (in %) in Bulgaria?
Offer a terse response. -3.51. In the year 2006, what is the difference between the Area (in %) in Sub-Saharan Africa (all income levels) and Area (in %) in Czech Republic?
Keep it short and to the point. -10.8. In the year 2006, what is the difference between the Area (in %) of Sub-Saharan Africa (all income levels) and Area (in %) of Nigeria?
Give a very brief answer. -36.22. In the year 2006, what is the difference between the Area (in %) in Bulgaria and Area (in %) in Czech Republic?
Offer a very short reply. -7.29. In the year 2006, what is the difference between the Area (in %) in Bulgaria and Area (in %) in Nigeria?
Ensure brevity in your answer.  -32.7. In the year 2006, what is the difference between the Area (in %) of Czech Republic and Area (in %) of Nigeria?
Make the answer very short. -25.41. In the year 2007, what is the difference between the Area (in %) in Sub-Saharan Africa (all income levels) and Area (in %) in Bulgaria?
Provide a short and direct response. -2.69. In the year 2007, what is the difference between the Area (in %) of Sub-Saharan Africa (all income levels) and Area (in %) of Czech Republic?
Make the answer very short. -10.59. In the year 2007, what is the difference between the Area (in %) of Sub-Saharan Africa (all income levels) and Area (in %) of Nigeria?
Provide a succinct answer. -36.51. In the year 2007, what is the difference between the Area (in %) of Bulgaria and Area (in %) of Czech Republic?
Your answer should be compact. -7.9. In the year 2007, what is the difference between the Area (in %) in Bulgaria and Area (in %) in Nigeria?
Provide a short and direct response. -33.82. In the year 2007, what is the difference between the Area (in %) of Czech Republic and Area (in %) of Nigeria?
Provide a short and direct response. -25.92. In the year 2008, what is the difference between the Area (in %) in Sub-Saharan Africa (all income levels) and Area (in %) in Bulgaria?
Your answer should be compact. -2.37. In the year 2008, what is the difference between the Area (in %) in Sub-Saharan Africa (all income levels) and Area (in %) in Czech Republic?
Offer a terse response. -10.35. In the year 2008, what is the difference between the Area (in %) in Sub-Saharan Africa (all income levels) and Area (in %) in Nigeria?
Your answer should be very brief. -35.23. In the year 2008, what is the difference between the Area (in %) of Bulgaria and Area (in %) of Czech Republic?
Ensure brevity in your answer.  -7.97. In the year 2008, what is the difference between the Area (in %) in Bulgaria and Area (in %) in Nigeria?
Keep it short and to the point. -32.86. In the year 2008, what is the difference between the Area (in %) of Czech Republic and Area (in %) of Nigeria?
Your answer should be very brief. -24.88. In the year 2009, what is the difference between the Area (in %) in Sub-Saharan Africa (all income levels) and Area (in %) in Bulgaria?
Provide a succinct answer. -1.78. In the year 2009, what is the difference between the Area (in %) of Sub-Saharan Africa (all income levels) and Area (in %) of Czech Republic?
Provide a succinct answer. -10.32. In the year 2009, what is the difference between the Area (in %) of Sub-Saharan Africa (all income levels) and Area (in %) of Nigeria?
Provide a succinct answer. -31.21. In the year 2009, what is the difference between the Area (in %) of Bulgaria and Area (in %) of Czech Republic?
Keep it short and to the point. -8.54. In the year 2009, what is the difference between the Area (in %) of Bulgaria and Area (in %) of Nigeria?
Provide a short and direct response. -29.43. In the year 2009, what is the difference between the Area (in %) in Czech Republic and Area (in %) in Nigeria?
Give a very brief answer. -20.89. What is the ratio of the Area (in %) in Sub-Saharan Africa (all income levels) in 2002 to that in 2003?
Your answer should be compact. 0.99. What is the ratio of the Area (in %) in Bulgaria in 2002 to that in 2003?
Your answer should be very brief. 1. What is the ratio of the Area (in %) of Czech Republic in 2002 to that in 2003?
Provide a short and direct response. 1. What is the ratio of the Area (in %) in Bulgaria in 2002 to that in 2004?
Your response must be concise. 1. What is the ratio of the Area (in %) of Czech Republic in 2002 to that in 2004?
Offer a terse response. 1. What is the ratio of the Area (in %) in Nigeria in 2002 to that in 2004?
Your answer should be compact. 0.98. What is the ratio of the Area (in %) of Sub-Saharan Africa (all income levels) in 2002 to that in 2005?
Make the answer very short. 0.98. What is the ratio of the Area (in %) in Bulgaria in 2002 to that in 2005?
Your response must be concise. 1.01. What is the ratio of the Area (in %) in Czech Republic in 2002 to that in 2005?
Keep it short and to the point. 1. What is the ratio of the Area (in %) in Nigeria in 2002 to that in 2005?
Provide a short and direct response. 0.97. What is the ratio of the Area (in %) in Sub-Saharan Africa (all income levels) in 2002 to that in 2006?
Keep it short and to the point. 0.98. What is the ratio of the Area (in %) of Bulgaria in 2002 to that in 2006?
Make the answer very short. 1.02. What is the ratio of the Area (in %) in Nigeria in 2002 to that in 2006?
Provide a succinct answer. 0.96. What is the ratio of the Area (in %) in Bulgaria in 2002 to that in 2007?
Provide a short and direct response. 1.04. What is the ratio of the Area (in %) of Czech Republic in 2002 to that in 2007?
Offer a terse response. 1.01. What is the ratio of the Area (in %) in Nigeria in 2002 to that in 2007?
Your response must be concise. 0.96. What is the ratio of the Area (in %) in Bulgaria in 2002 to that in 2008?
Give a very brief answer. 1.04. What is the ratio of the Area (in %) in Nigeria in 2002 to that in 2008?
Make the answer very short. 0.97. What is the ratio of the Area (in %) of Sub-Saharan Africa (all income levels) in 2002 to that in 2009?
Keep it short and to the point. 0.97. What is the ratio of the Area (in %) in Bulgaria in 2002 to that in 2009?
Make the answer very short. 1.06. What is the ratio of the Area (in %) of Czech Republic in 2002 to that in 2009?
Your answer should be compact. 1.01. What is the ratio of the Area (in %) of Nigeria in 2002 to that in 2009?
Ensure brevity in your answer.  1.02. What is the ratio of the Area (in %) of Czech Republic in 2003 to that in 2004?
Offer a very short reply. 1. What is the ratio of the Area (in %) of Bulgaria in 2003 to that in 2005?
Provide a short and direct response. 1.01. What is the ratio of the Area (in %) in Czech Republic in 2003 to that in 2005?
Provide a short and direct response. 1. What is the ratio of the Area (in %) in Nigeria in 2003 to that in 2005?
Keep it short and to the point. 0.99. What is the ratio of the Area (in %) in Sub-Saharan Africa (all income levels) in 2003 to that in 2006?
Give a very brief answer. 0.99. What is the ratio of the Area (in %) of Bulgaria in 2003 to that in 2006?
Your answer should be compact. 1.02. What is the ratio of the Area (in %) in Nigeria in 2003 to that in 2006?
Give a very brief answer. 0.98. What is the ratio of the Area (in %) of Sub-Saharan Africa (all income levels) in 2003 to that in 2007?
Offer a terse response. 0.98. What is the ratio of the Area (in %) of Bulgaria in 2003 to that in 2007?
Offer a very short reply. 1.04. What is the ratio of the Area (in %) in Nigeria in 2003 to that in 2007?
Your response must be concise. 0.97. What is the ratio of the Area (in %) in Sub-Saharan Africa (all income levels) in 2003 to that in 2008?
Keep it short and to the point. 0.98. What is the ratio of the Area (in %) of Bulgaria in 2003 to that in 2008?
Provide a succinct answer. 1.04. What is the ratio of the Area (in %) in Czech Republic in 2003 to that in 2008?
Offer a terse response. 1.01. What is the ratio of the Area (in %) in Nigeria in 2003 to that in 2008?
Keep it short and to the point. 0.99. What is the ratio of the Area (in %) of Sub-Saharan Africa (all income levels) in 2003 to that in 2009?
Your answer should be very brief. 0.98. What is the ratio of the Area (in %) of Bulgaria in 2003 to that in 2009?
Your answer should be very brief. 1.06. What is the ratio of the Area (in %) of Czech Republic in 2003 to that in 2009?
Your response must be concise. 1.01. What is the ratio of the Area (in %) of Nigeria in 2003 to that in 2009?
Your answer should be very brief. 1.04. What is the ratio of the Area (in %) of Sub-Saharan Africa (all income levels) in 2004 to that in 2005?
Provide a short and direct response. 0.99. What is the ratio of the Area (in %) in Bulgaria in 2004 to that in 2005?
Your answer should be compact. 1.01. What is the ratio of the Area (in %) of Nigeria in 2004 to that in 2005?
Ensure brevity in your answer.  0.99. What is the ratio of the Area (in %) of Bulgaria in 2004 to that in 2006?
Offer a terse response. 1.03. What is the ratio of the Area (in %) in Nigeria in 2004 to that in 2006?
Your answer should be very brief. 0.98. What is the ratio of the Area (in %) of Sub-Saharan Africa (all income levels) in 2004 to that in 2007?
Provide a short and direct response. 0.99. What is the ratio of the Area (in %) in Bulgaria in 2004 to that in 2007?
Your answer should be compact. 1.04. What is the ratio of the Area (in %) in Czech Republic in 2004 to that in 2007?
Provide a short and direct response. 1. What is the ratio of the Area (in %) in Nigeria in 2004 to that in 2007?
Your answer should be very brief. 0.97. What is the ratio of the Area (in %) of Sub-Saharan Africa (all income levels) in 2004 to that in 2008?
Give a very brief answer. 0.98. What is the ratio of the Area (in %) in Bulgaria in 2004 to that in 2008?
Your answer should be very brief. 1.04. What is the ratio of the Area (in %) in Czech Republic in 2004 to that in 2008?
Your answer should be compact. 1. What is the ratio of the Area (in %) in Nigeria in 2004 to that in 2008?
Provide a succinct answer. 0.99. What is the ratio of the Area (in %) in Sub-Saharan Africa (all income levels) in 2004 to that in 2009?
Make the answer very short. 0.98. What is the ratio of the Area (in %) in Bulgaria in 2004 to that in 2009?
Your answer should be very brief. 1.06. What is the ratio of the Area (in %) of Czech Republic in 2004 to that in 2009?
Your answer should be very brief. 1.01. What is the ratio of the Area (in %) of Nigeria in 2004 to that in 2009?
Provide a succinct answer. 1.04. What is the ratio of the Area (in %) of Bulgaria in 2005 to that in 2006?
Provide a short and direct response. 1.01. What is the ratio of the Area (in %) of Bulgaria in 2005 to that in 2007?
Your answer should be very brief. 1.03. What is the ratio of the Area (in %) in Czech Republic in 2005 to that in 2007?
Provide a succinct answer. 1. What is the ratio of the Area (in %) in Nigeria in 2005 to that in 2007?
Your answer should be compact. 0.99. What is the ratio of the Area (in %) in Bulgaria in 2005 to that in 2008?
Your response must be concise. 1.03. What is the ratio of the Area (in %) of Czech Republic in 2005 to that in 2008?
Give a very brief answer. 1. What is the ratio of the Area (in %) in Nigeria in 2005 to that in 2008?
Give a very brief answer. 1. What is the ratio of the Area (in %) in Bulgaria in 2005 to that in 2009?
Keep it short and to the point. 1.05. What is the ratio of the Area (in %) in Czech Republic in 2005 to that in 2009?
Make the answer very short. 1. What is the ratio of the Area (in %) of Nigeria in 2005 to that in 2009?
Your response must be concise. 1.05. What is the ratio of the Area (in %) of Bulgaria in 2006 to that in 2007?
Provide a short and direct response. 1.01. What is the ratio of the Area (in %) of Czech Republic in 2006 to that in 2007?
Keep it short and to the point. 1. What is the ratio of the Area (in %) of Nigeria in 2006 to that in 2007?
Give a very brief answer. 0.99. What is the ratio of the Area (in %) in Bulgaria in 2006 to that in 2008?
Ensure brevity in your answer.  1.02. What is the ratio of the Area (in %) of Czech Republic in 2006 to that in 2008?
Offer a terse response. 1. What is the ratio of the Area (in %) in Nigeria in 2006 to that in 2008?
Your answer should be very brief. 1.01. What is the ratio of the Area (in %) in Bulgaria in 2006 to that in 2009?
Your answer should be very brief. 1.03. What is the ratio of the Area (in %) of Czech Republic in 2006 to that in 2009?
Your answer should be very brief. 1. What is the ratio of the Area (in %) in Nigeria in 2006 to that in 2009?
Provide a succinct answer. 1.06. What is the ratio of the Area (in %) of Sub-Saharan Africa (all income levels) in 2007 to that in 2008?
Give a very brief answer. 1. What is the ratio of the Area (in %) of Bulgaria in 2007 to that in 2008?
Your answer should be very brief. 1. What is the ratio of the Area (in %) of Czech Republic in 2007 to that in 2008?
Offer a very short reply. 1. What is the ratio of the Area (in %) in Nigeria in 2007 to that in 2008?
Ensure brevity in your answer.  1.01. What is the ratio of the Area (in %) in Bulgaria in 2007 to that in 2009?
Ensure brevity in your answer.  1.02. What is the ratio of the Area (in %) of Nigeria in 2007 to that in 2009?
Your answer should be compact. 1.07. What is the ratio of the Area (in %) in Bulgaria in 2008 to that in 2009?
Your response must be concise. 1.01. What is the ratio of the Area (in %) of Nigeria in 2008 to that in 2009?
Your answer should be very brief. 1.05. What is the difference between the highest and the second highest Area (in %) in Sub-Saharan Africa (all income levels)?
Keep it short and to the point. 0.04. What is the difference between the highest and the second highest Area (in %) in Bulgaria?
Make the answer very short. 0.04. What is the difference between the highest and the second highest Area (in %) in Czech Republic?
Provide a short and direct response. 0.04. What is the difference between the highest and the second highest Area (in %) of Nigeria?
Keep it short and to the point. 0.44. What is the difference between the highest and the lowest Area (in %) of Sub-Saharan Africa (all income levels)?
Keep it short and to the point. 1.25. What is the difference between the highest and the lowest Area (in %) of Bulgaria?
Ensure brevity in your answer.  2.67. What is the difference between the highest and the lowest Area (in %) in Czech Republic?
Your response must be concise. 0.41. What is the difference between the highest and the lowest Area (in %) of Nigeria?
Provide a short and direct response. 5.16. 